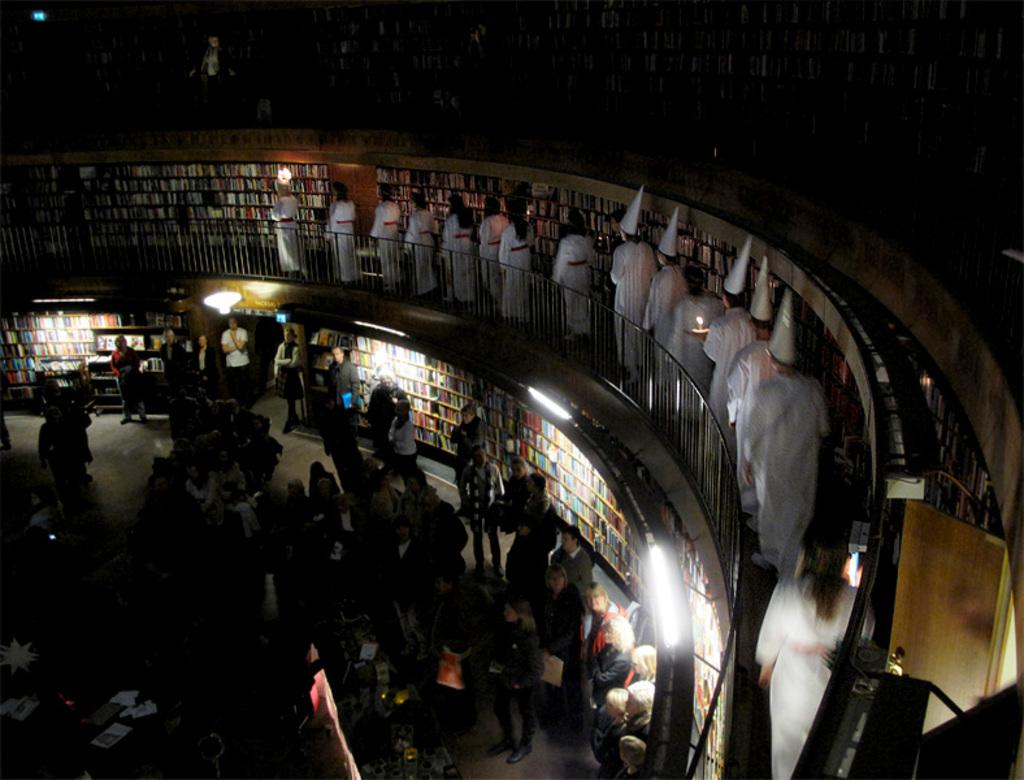Who is present in the image? There are people in the image. What are the people wearing? The people are wearing white dresses. Where are the people located in the image? The people are standing in a balcony. Are there any accessories visible on the people? Some people are wearing caps. Can you describe the people at the bottom of the image? There are people visible at the bottom of the image. What is the color of the walls in the image? There are colorful walls in the image. What else can be seen in the image? There are lights visible in the image. What type of kite is being flown by the people in the image? There is no kite present in the image; the people are standing in a balcony wearing white dresses and caps. 